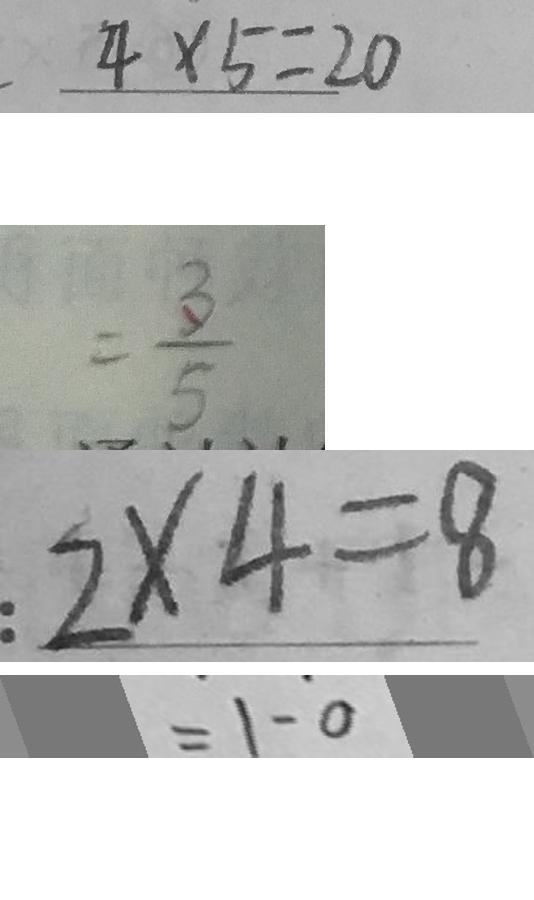Convert formula to latex. <formula><loc_0><loc_0><loc_500><loc_500>. 4 \times 5 = 2 0 
 = \frac { 3 } { 5 } 
 : 2 \times 4 = 8 
 = 1 - 0</formula> 